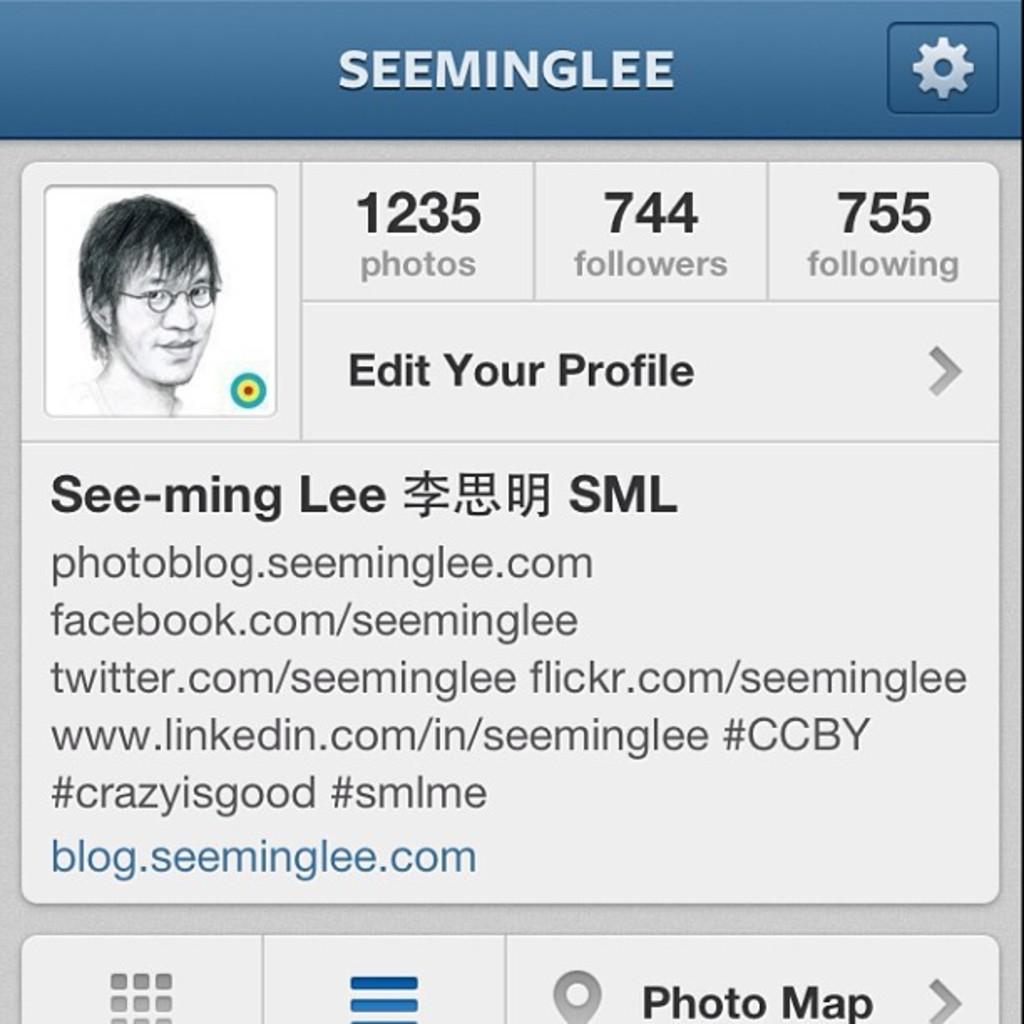What type of image is shown in the picture? The image appears to be a profile of a person. Where might this profile be found? The profile is likely to be found on a social site. How many people are having dinner in the image? There is no dinner or people present in the image; it is a profile of a person. 